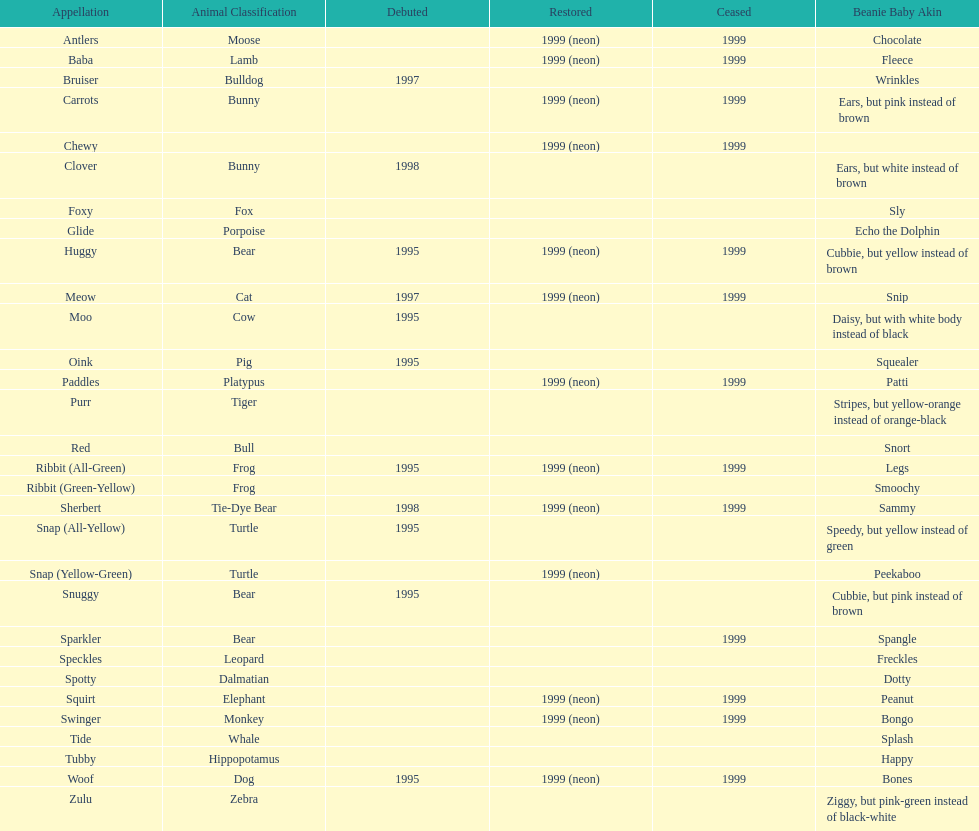How long was woof the dog sold before it was retired? 4 years. Can you give me this table as a dict? {'header': ['Appellation', 'Animal Classification', 'Debuted', 'Restored', 'Ceased', 'Beanie Baby Akin'], 'rows': [['Antlers', 'Moose', '', '1999 (neon)', '1999', 'Chocolate'], ['Baba', 'Lamb', '', '1999 (neon)', '1999', 'Fleece'], ['Bruiser', 'Bulldog', '1997', '', '', 'Wrinkles'], ['Carrots', 'Bunny', '', '1999 (neon)', '1999', 'Ears, but pink instead of brown'], ['Chewy', '', '', '1999 (neon)', '1999', ''], ['Clover', 'Bunny', '1998', '', '', 'Ears, but white instead of brown'], ['Foxy', 'Fox', '', '', '', 'Sly'], ['Glide', 'Porpoise', '', '', '', 'Echo the Dolphin'], ['Huggy', 'Bear', '1995', '1999 (neon)', '1999', 'Cubbie, but yellow instead of brown'], ['Meow', 'Cat', '1997', '1999 (neon)', '1999', 'Snip'], ['Moo', 'Cow', '1995', '', '', 'Daisy, but with white body instead of black'], ['Oink', 'Pig', '1995', '', '', 'Squealer'], ['Paddles', 'Platypus', '', '1999 (neon)', '1999', 'Patti'], ['Purr', 'Tiger', '', '', '', 'Stripes, but yellow-orange instead of orange-black'], ['Red', 'Bull', '', '', '', 'Snort'], ['Ribbit (All-Green)', 'Frog', '1995', '1999 (neon)', '1999', 'Legs'], ['Ribbit (Green-Yellow)', 'Frog', '', '', '', 'Smoochy'], ['Sherbert', 'Tie-Dye Bear', '1998', '1999 (neon)', '1999', 'Sammy'], ['Snap (All-Yellow)', 'Turtle', '1995', '', '', 'Speedy, but yellow instead of green'], ['Snap (Yellow-Green)', 'Turtle', '', '1999 (neon)', '', 'Peekaboo'], ['Snuggy', 'Bear', '1995', '', '', 'Cubbie, but pink instead of brown'], ['Sparkler', 'Bear', '', '', '1999', 'Spangle'], ['Speckles', 'Leopard', '', '', '', 'Freckles'], ['Spotty', 'Dalmatian', '', '', '', 'Dotty'], ['Squirt', 'Elephant', '', '1999 (neon)', '1999', 'Peanut'], ['Swinger', 'Monkey', '', '1999 (neon)', '1999', 'Bongo'], ['Tide', 'Whale', '', '', '', 'Splash'], ['Tubby', 'Hippopotamus', '', '', '', 'Happy'], ['Woof', 'Dog', '1995', '1999 (neon)', '1999', 'Bones'], ['Zulu', 'Zebra', '', '', '', 'Ziggy, but pink-green instead of black-white']]} 